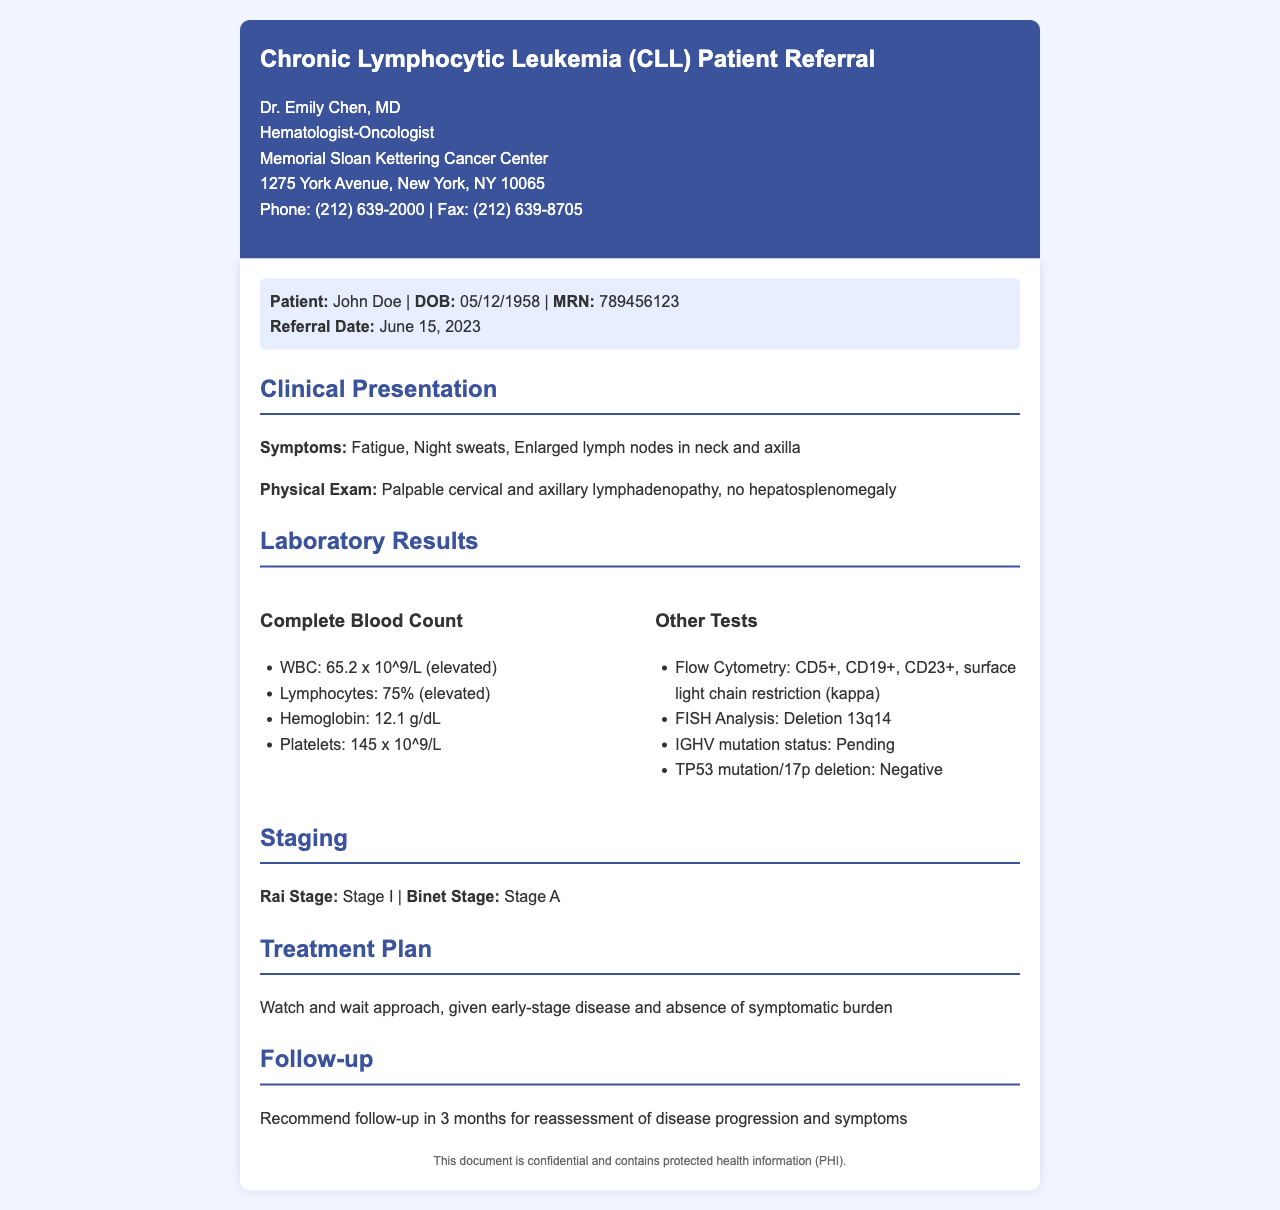What is the patient's name? The patient's name is clearly stated in the document under patient information.
Answer: John Doe What is the referral date? The referral date is mentioned in the patient information section of the document.
Answer: June 15, 2023 What is the patient's hemoglobin level? The hemoglobin level can be found in the Complete Blood Count section under laboratory results.
Answer: 12.1 g/dL What is the Rai Stage of the patient? The Rai Stage is indicated in the staging section of the document.
Answer: Stage I What is the treatment plan? The treatment plan is described in the corresponding section of the document.
Answer: Watch and wait approach What is the percentage of lymphocytes in the Complete Blood Count? The lymphocyte percentage is listed in the Complete Blood Count section.
Answer: 75% What are the results of the TP53 mutation/17p deletion test? This result is found in the Other Tests section, indicating related genetic tests.
Answer: Negative What is the recommended follow-up period? The recommended follow-up is stated in the follow-up section.
Answer: 3 months What institution is Dr. Emily Chen affiliated with? This information is located in the header section of the document.
Answer: Memorial Sloan Kettering Cancer Center 